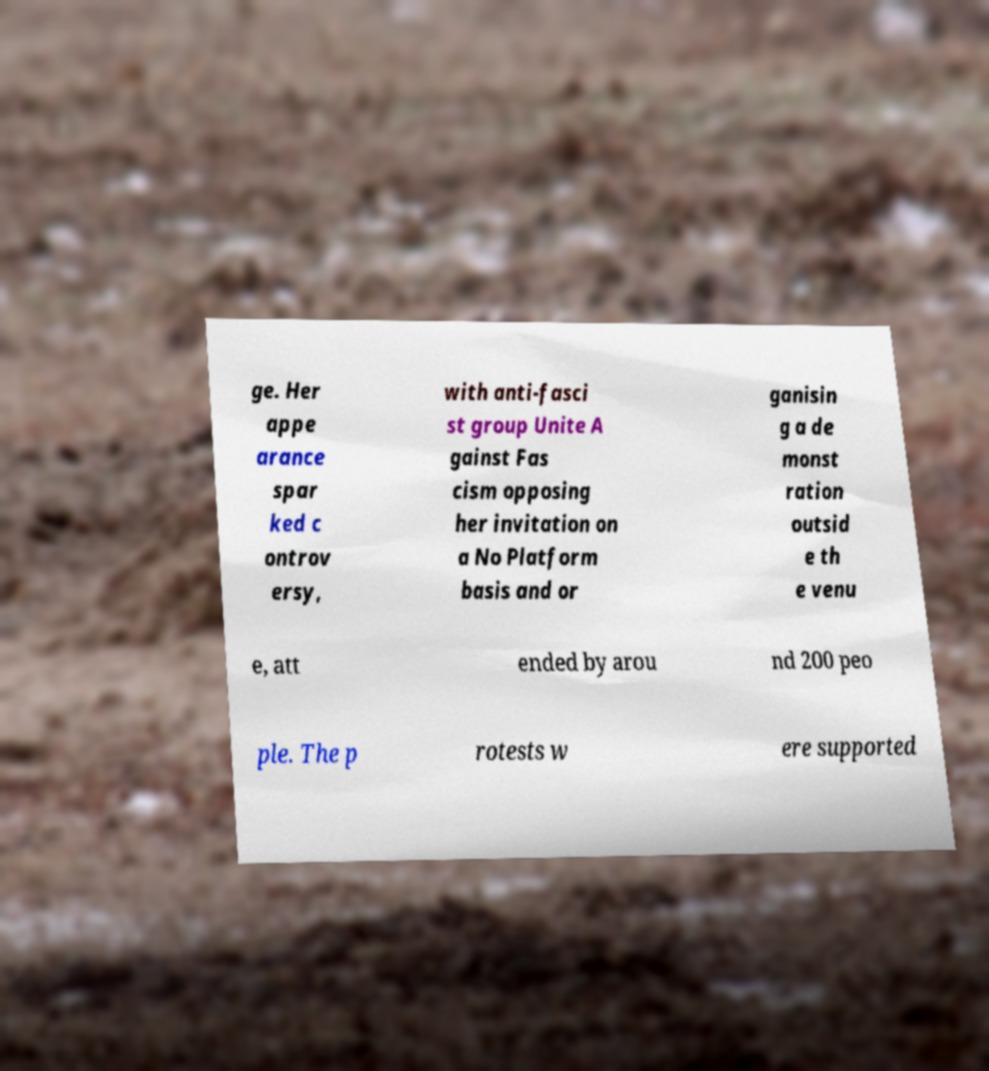What messages or text are displayed in this image? I need them in a readable, typed format. ge. Her appe arance spar ked c ontrov ersy, with anti-fasci st group Unite A gainst Fas cism opposing her invitation on a No Platform basis and or ganisin g a de monst ration outsid e th e venu e, att ended by arou nd 200 peo ple. The p rotests w ere supported 